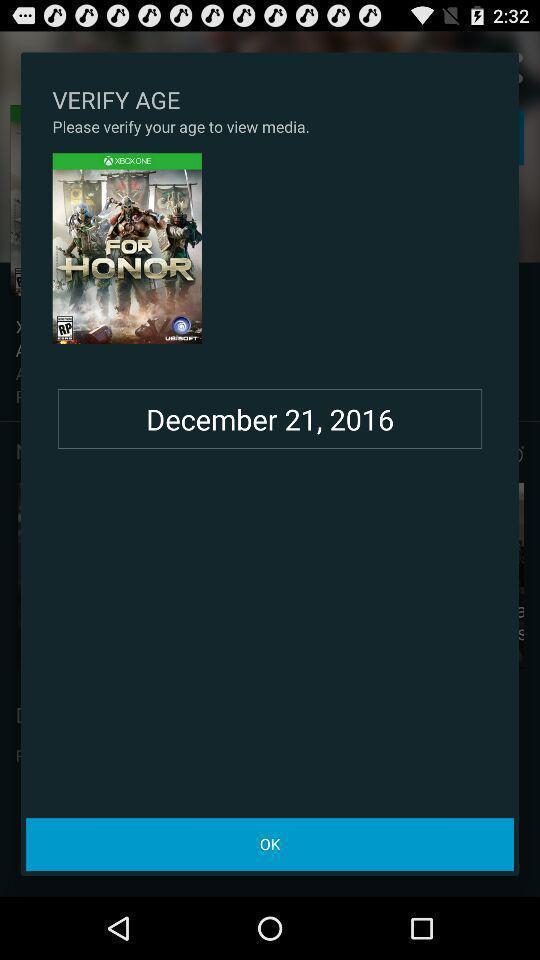Describe the content in this image. Window displaying a game app. 